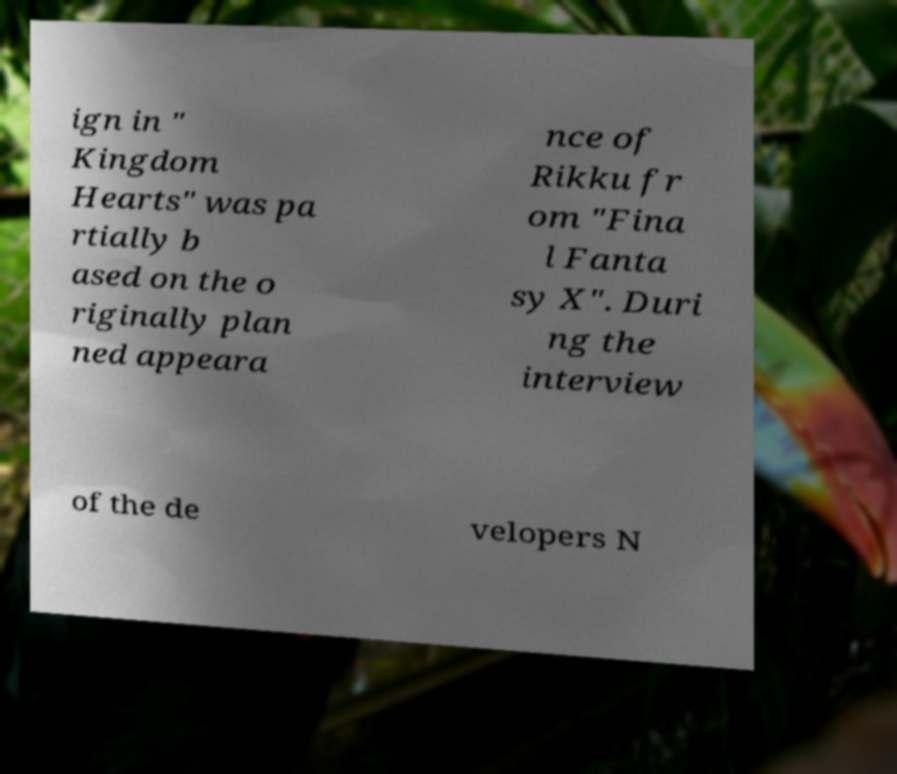Can you accurately transcribe the text from the provided image for me? ign in " Kingdom Hearts" was pa rtially b ased on the o riginally plan ned appeara nce of Rikku fr om "Fina l Fanta sy X". Duri ng the interview of the de velopers N 